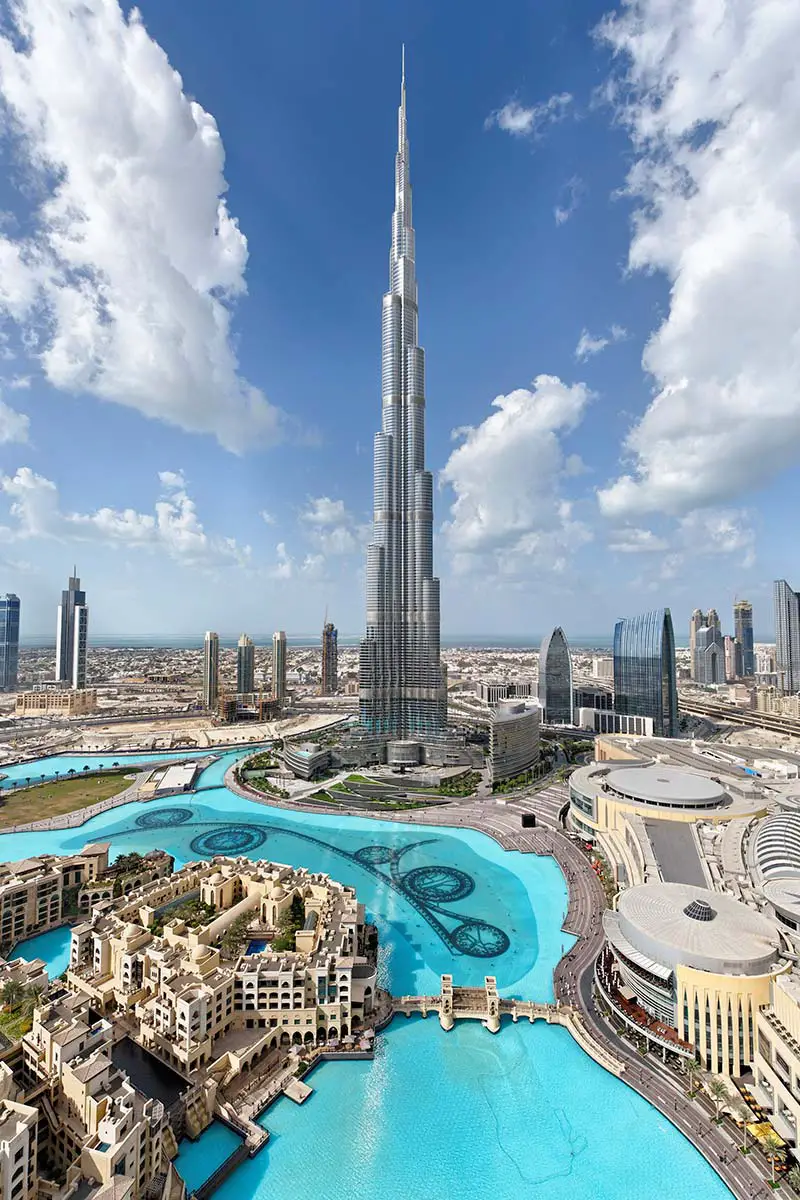How does the Burj Khalifa compare to the surrounding buildings? The Burj Khalifa is not just the central piece of the Dubai skyline but a pinnacle of human engineering that dwarfs the surrounding structures. Its sheer height and the tiered design mark a stark contrast, overshadowing neighboring skyscrapers and asserting its status as a globally recognized landmark. The neighboring buildings, while impressive in their own right, serve as a testament to Dubai's architectural variety and urban development. What can you tell me about the body of water around the structures? The expansive body of water is the Dubai Fountain, the world's largest choreographed fountain system. It's set on the 30-acre manmade Burj Khalifa Lake at the center of the Downtown Dubai development. This water feature is not only a visual spectacle but also serves as a harmonizing element that accentuates the towering presence of the Burj Khalifa and provides a cooling effect in the arid desert environment. 